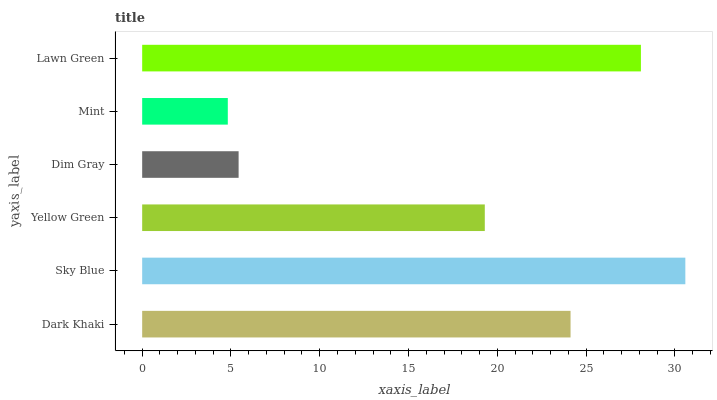Is Mint the minimum?
Answer yes or no. Yes. Is Sky Blue the maximum?
Answer yes or no. Yes. Is Yellow Green the minimum?
Answer yes or no. No. Is Yellow Green the maximum?
Answer yes or no. No. Is Sky Blue greater than Yellow Green?
Answer yes or no. Yes. Is Yellow Green less than Sky Blue?
Answer yes or no. Yes. Is Yellow Green greater than Sky Blue?
Answer yes or no. No. Is Sky Blue less than Yellow Green?
Answer yes or no. No. Is Dark Khaki the high median?
Answer yes or no. Yes. Is Yellow Green the low median?
Answer yes or no. Yes. Is Dim Gray the high median?
Answer yes or no. No. Is Mint the low median?
Answer yes or no. No. 